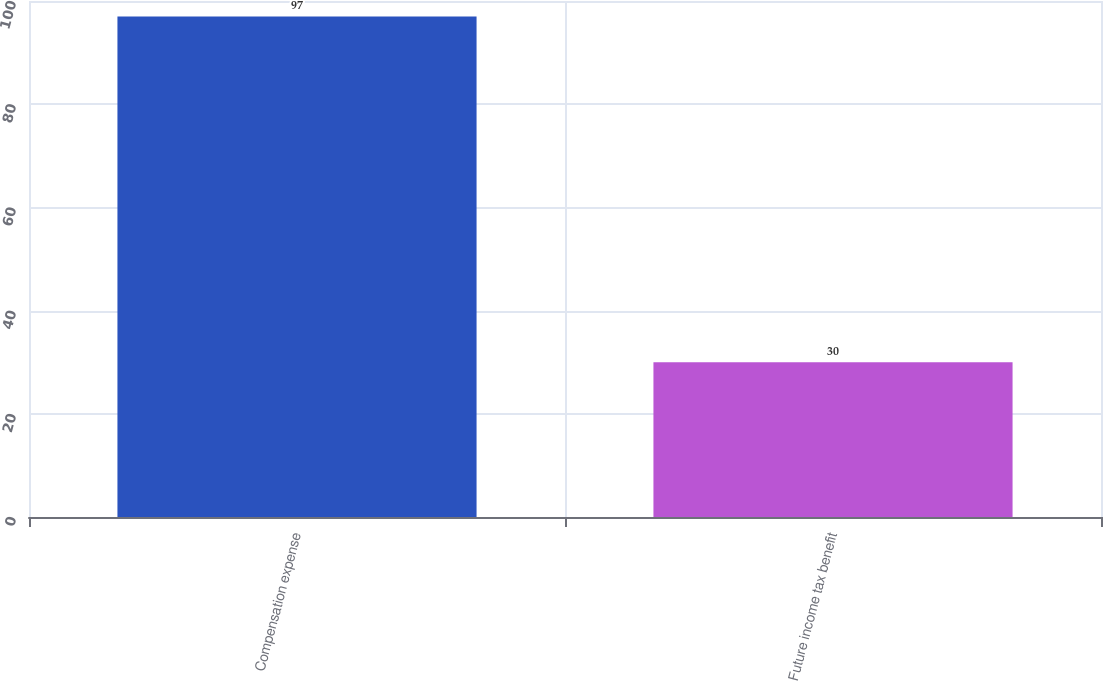Convert chart to OTSL. <chart><loc_0><loc_0><loc_500><loc_500><bar_chart><fcel>Compensation expense<fcel>Future income tax benefit<nl><fcel>97<fcel>30<nl></chart> 